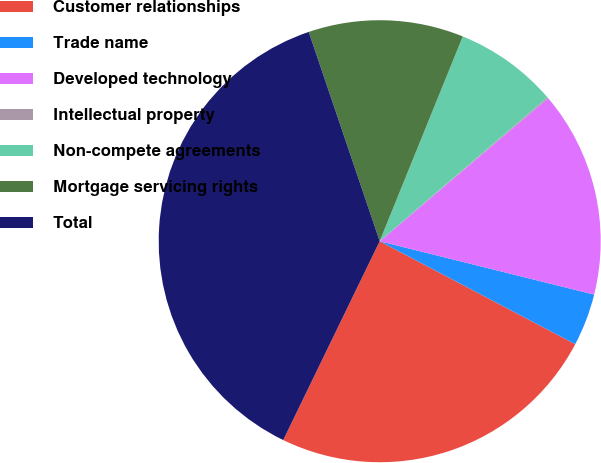Convert chart. <chart><loc_0><loc_0><loc_500><loc_500><pie_chart><fcel>Customer relationships<fcel>Trade name<fcel>Developed technology<fcel>Intellectual property<fcel>Non-compete agreements<fcel>Mortgage servicing rights<fcel>Total<nl><fcel>24.48%<fcel>3.83%<fcel>15.09%<fcel>0.08%<fcel>7.58%<fcel>11.34%<fcel>37.61%<nl></chart> 